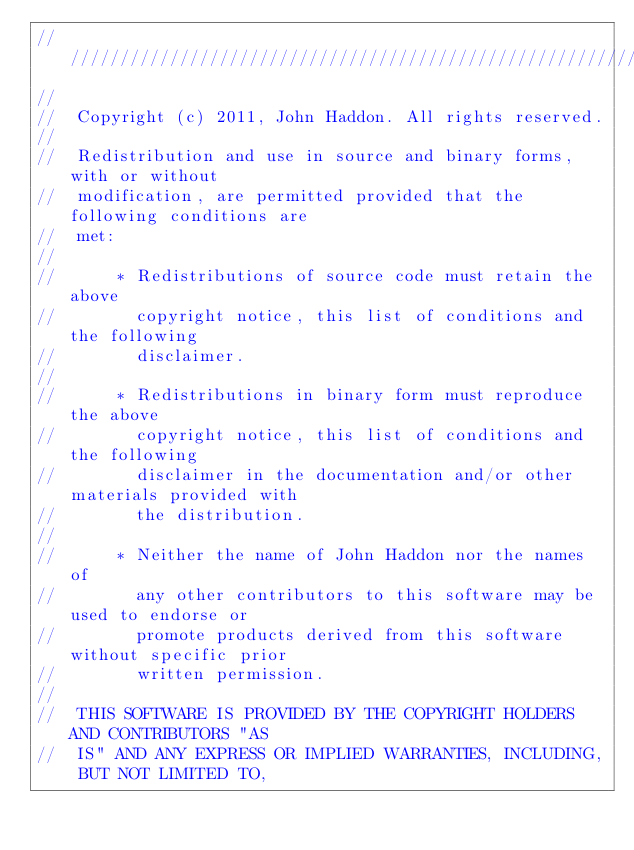<code> <loc_0><loc_0><loc_500><loc_500><_C_>//////////////////////////////////////////////////////////////////////////
//  
//  Copyright (c) 2011, John Haddon. All rights reserved.
//  
//  Redistribution and use in source and binary forms, with or without
//  modification, are permitted provided that the following conditions are
//  met:
//  
//      * Redistributions of source code must retain the above
//        copyright notice, this list of conditions and the following
//        disclaimer.
//  
//      * Redistributions in binary form must reproduce the above
//        copyright notice, this list of conditions and the following
//        disclaimer in the documentation and/or other materials provided with
//        the distribution.
//  
//      * Neither the name of John Haddon nor the names of
//        any other contributors to this software may be used to endorse or
//        promote products derived from this software without specific prior
//        written permission.
//  
//  THIS SOFTWARE IS PROVIDED BY THE COPYRIGHT HOLDERS AND CONTRIBUTORS "AS
//  IS" AND ANY EXPRESS OR IMPLIED WARRANTIES, INCLUDING, BUT NOT LIMITED TO,</code> 